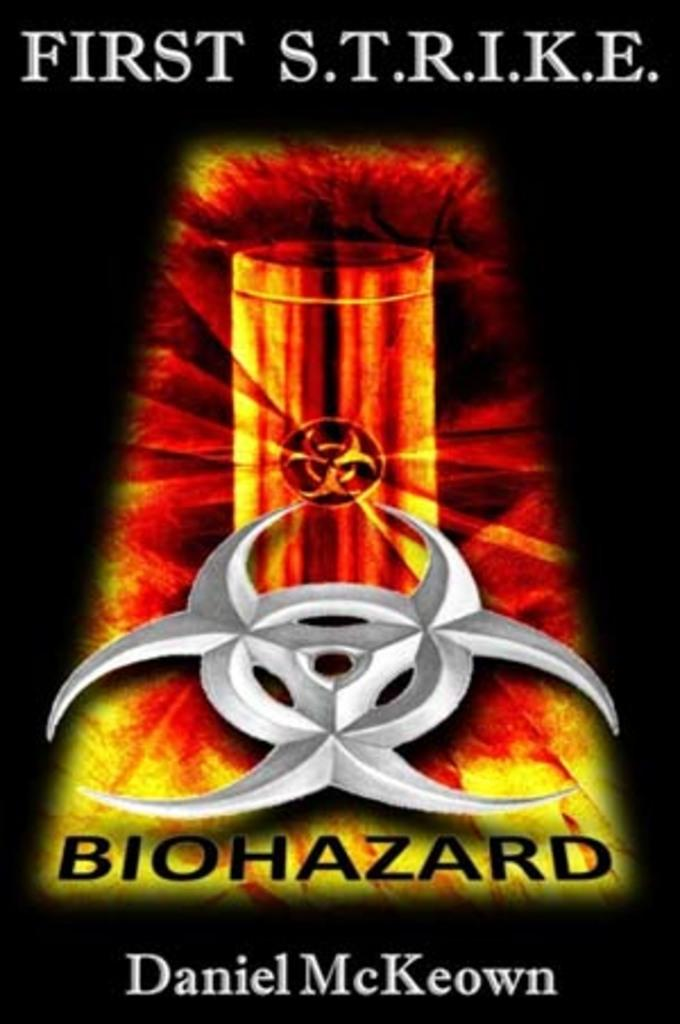<image>
Share a concise interpretation of the image provided. The cover of the book First S.T.R.I.K.E. written by Daniel McKeown. 